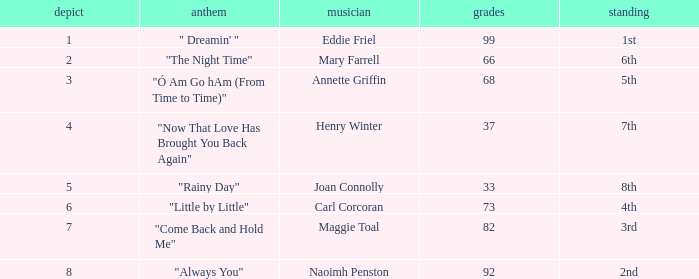What is the average number of points when the ranking is 7th and the draw is less than 4? None. 